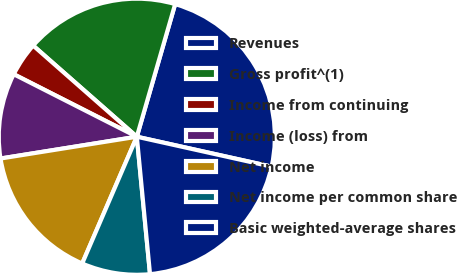<chart> <loc_0><loc_0><loc_500><loc_500><pie_chart><fcel>Revenues<fcel>Gross profit^(1)<fcel>Income from continuing<fcel>Income (loss) from<fcel>Net income<fcel>Net income per common share<fcel>Basic weighted-average shares<nl><fcel>24.0%<fcel>18.0%<fcel>4.0%<fcel>10.0%<fcel>16.0%<fcel>8.0%<fcel>20.0%<nl></chart> 